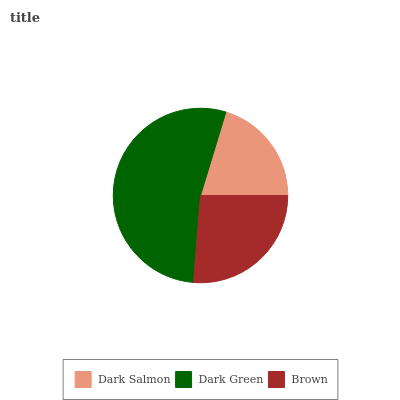Is Dark Salmon the minimum?
Answer yes or no. Yes. Is Dark Green the maximum?
Answer yes or no. Yes. Is Brown the minimum?
Answer yes or no. No. Is Brown the maximum?
Answer yes or no. No. Is Dark Green greater than Brown?
Answer yes or no. Yes. Is Brown less than Dark Green?
Answer yes or no. Yes. Is Brown greater than Dark Green?
Answer yes or no. No. Is Dark Green less than Brown?
Answer yes or no. No. Is Brown the high median?
Answer yes or no. Yes. Is Brown the low median?
Answer yes or no. Yes. Is Dark Green the high median?
Answer yes or no. No. Is Dark Green the low median?
Answer yes or no. No. 